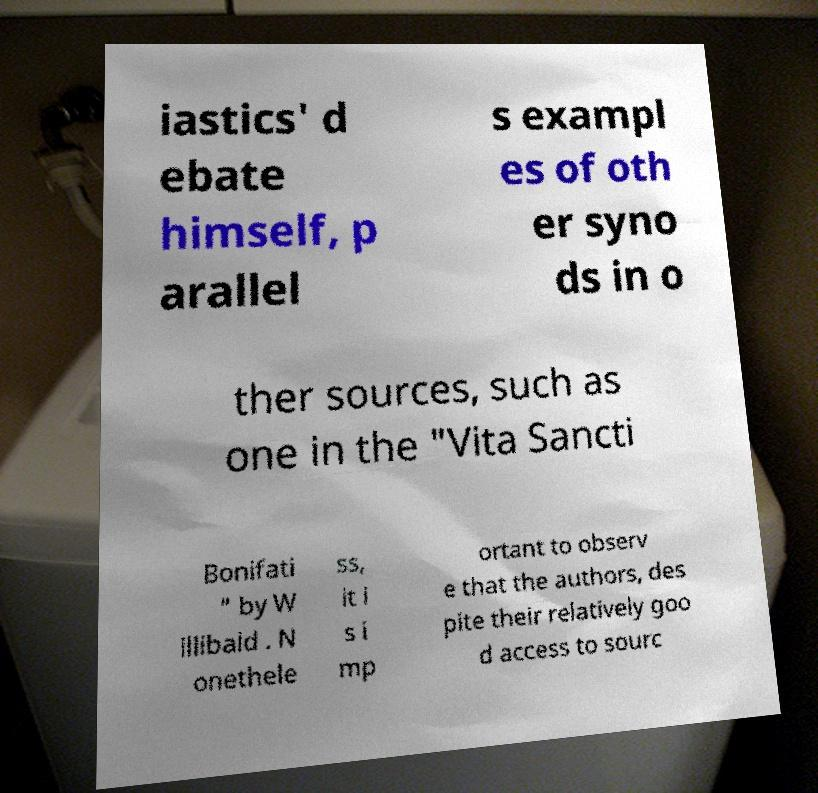For documentation purposes, I need the text within this image transcribed. Could you provide that? iastics' d ebate himself, p arallel s exampl es of oth er syno ds in o ther sources, such as one in the "Vita Sancti Bonifati " by W illibald . N onethele ss, it i s i mp ortant to observ e that the authors, des pite their relatively goo d access to sourc 